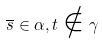Convert formula to latex. <formula><loc_0><loc_0><loc_500><loc_500>\overline { s } \in \alpha , t \notin \gamma</formula> 